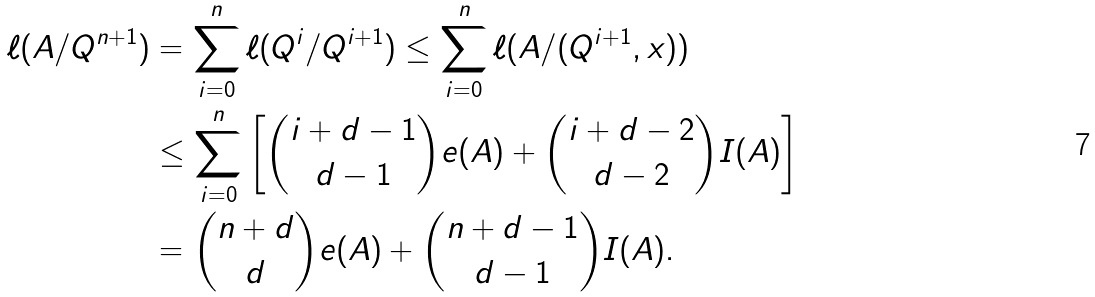Convert formula to latex. <formula><loc_0><loc_0><loc_500><loc_500>\ell ( A / Q ^ { n + 1 } ) & = \sum _ { i = 0 } ^ { n } \ell ( Q ^ { i } / Q ^ { i + 1 } ) \leq \sum _ { i = 0 } ^ { n } \ell ( A / ( Q ^ { i + 1 } , x ) ) \\ & \leq \sum _ { i = 0 } ^ { n } \left [ { i + d - 1 \choose d - 1 } e ( A ) + { i + d - 2 \choose d - 2 } I ( A ) \right ] \\ & = { n + d \choose d } e ( A ) + { n + d - 1 \choose d - 1 } I ( A ) .</formula> 